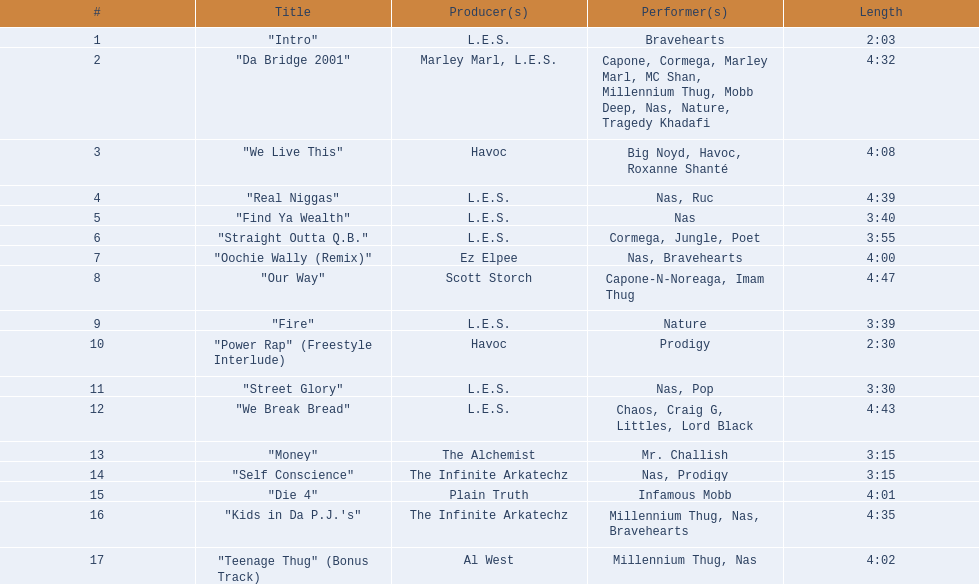Post street glory, which melody is specified? "We Break Bread". 